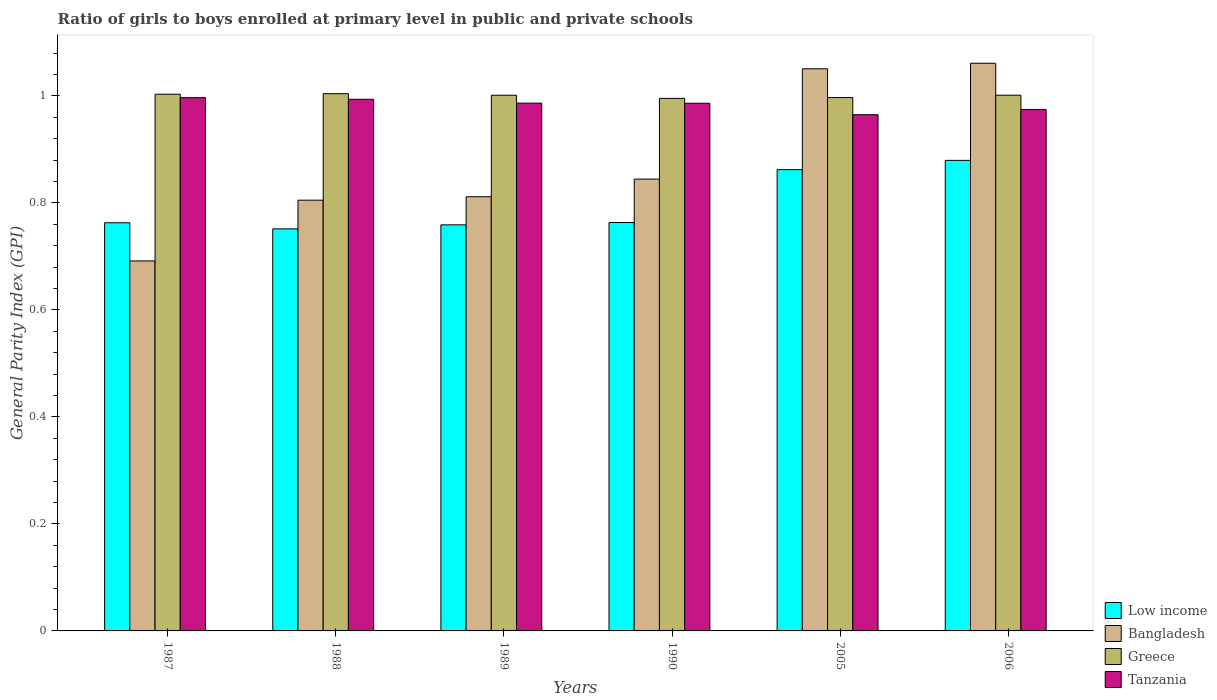How many different coloured bars are there?
Offer a terse response. 4. How many groups of bars are there?
Your answer should be very brief. 6. Are the number of bars per tick equal to the number of legend labels?
Ensure brevity in your answer.  Yes. How many bars are there on the 6th tick from the left?
Your answer should be very brief. 4. How many bars are there on the 2nd tick from the right?
Make the answer very short. 4. In how many cases, is the number of bars for a given year not equal to the number of legend labels?
Your answer should be compact. 0. What is the general parity index in Tanzania in 1988?
Your response must be concise. 0.99. Across all years, what is the maximum general parity index in Greece?
Give a very brief answer. 1. Across all years, what is the minimum general parity index in Greece?
Ensure brevity in your answer.  1. In which year was the general parity index in Bangladesh maximum?
Provide a short and direct response. 2006. What is the total general parity index in Bangladesh in the graph?
Offer a very short reply. 5.26. What is the difference between the general parity index in Tanzania in 1987 and that in 1990?
Make the answer very short. 0.01. What is the difference between the general parity index in Low income in 2005 and the general parity index in Bangladesh in 1989?
Make the answer very short. 0.05. What is the average general parity index in Low income per year?
Your response must be concise. 0.8. In the year 1987, what is the difference between the general parity index in Bangladesh and general parity index in Greece?
Your response must be concise. -0.31. In how many years, is the general parity index in Greece greater than 0.68?
Make the answer very short. 6. What is the ratio of the general parity index in Tanzania in 1987 to that in 2005?
Provide a short and direct response. 1.03. What is the difference between the highest and the second highest general parity index in Greece?
Your answer should be very brief. 0. What is the difference between the highest and the lowest general parity index in Low income?
Offer a terse response. 0.13. In how many years, is the general parity index in Greece greater than the average general parity index in Greece taken over all years?
Ensure brevity in your answer.  4. What does the 1st bar from the right in 1987 represents?
Provide a short and direct response. Tanzania. Is it the case that in every year, the sum of the general parity index in Bangladesh and general parity index in Low income is greater than the general parity index in Tanzania?
Offer a terse response. Yes. How many bars are there?
Provide a short and direct response. 24. Are all the bars in the graph horizontal?
Your answer should be very brief. No. Where does the legend appear in the graph?
Your response must be concise. Bottom right. What is the title of the graph?
Your answer should be compact. Ratio of girls to boys enrolled at primary level in public and private schools. What is the label or title of the X-axis?
Offer a very short reply. Years. What is the label or title of the Y-axis?
Your answer should be compact. General Parity Index (GPI). What is the General Parity Index (GPI) of Low income in 1987?
Give a very brief answer. 0.76. What is the General Parity Index (GPI) of Bangladesh in 1987?
Make the answer very short. 0.69. What is the General Parity Index (GPI) in Greece in 1987?
Ensure brevity in your answer.  1. What is the General Parity Index (GPI) in Tanzania in 1987?
Provide a short and direct response. 1. What is the General Parity Index (GPI) of Low income in 1988?
Offer a very short reply. 0.75. What is the General Parity Index (GPI) of Bangladesh in 1988?
Make the answer very short. 0.81. What is the General Parity Index (GPI) in Greece in 1988?
Give a very brief answer. 1. What is the General Parity Index (GPI) in Tanzania in 1988?
Your answer should be compact. 0.99. What is the General Parity Index (GPI) in Low income in 1989?
Keep it short and to the point. 0.76. What is the General Parity Index (GPI) of Bangladesh in 1989?
Give a very brief answer. 0.81. What is the General Parity Index (GPI) of Greece in 1989?
Provide a short and direct response. 1. What is the General Parity Index (GPI) of Tanzania in 1989?
Make the answer very short. 0.99. What is the General Parity Index (GPI) of Low income in 1990?
Ensure brevity in your answer.  0.76. What is the General Parity Index (GPI) in Bangladesh in 1990?
Offer a terse response. 0.84. What is the General Parity Index (GPI) in Greece in 1990?
Your response must be concise. 1. What is the General Parity Index (GPI) in Tanzania in 1990?
Keep it short and to the point. 0.99. What is the General Parity Index (GPI) of Low income in 2005?
Offer a terse response. 0.86. What is the General Parity Index (GPI) of Bangladesh in 2005?
Ensure brevity in your answer.  1.05. What is the General Parity Index (GPI) in Greece in 2005?
Offer a terse response. 1. What is the General Parity Index (GPI) of Tanzania in 2005?
Offer a very short reply. 0.96. What is the General Parity Index (GPI) in Low income in 2006?
Your response must be concise. 0.88. What is the General Parity Index (GPI) of Bangladesh in 2006?
Offer a very short reply. 1.06. What is the General Parity Index (GPI) of Greece in 2006?
Your response must be concise. 1. What is the General Parity Index (GPI) in Tanzania in 2006?
Give a very brief answer. 0.97. Across all years, what is the maximum General Parity Index (GPI) of Low income?
Offer a terse response. 0.88. Across all years, what is the maximum General Parity Index (GPI) in Bangladesh?
Your answer should be compact. 1.06. Across all years, what is the maximum General Parity Index (GPI) in Greece?
Offer a very short reply. 1. Across all years, what is the maximum General Parity Index (GPI) of Tanzania?
Make the answer very short. 1. Across all years, what is the minimum General Parity Index (GPI) in Low income?
Your answer should be very brief. 0.75. Across all years, what is the minimum General Parity Index (GPI) of Bangladesh?
Offer a very short reply. 0.69. Across all years, what is the minimum General Parity Index (GPI) of Greece?
Provide a short and direct response. 1. Across all years, what is the minimum General Parity Index (GPI) in Tanzania?
Your response must be concise. 0.96. What is the total General Parity Index (GPI) in Low income in the graph?
Keep it short and to the point. 4.78. What is the total General Parity Index (GPI) in Bangladesh in the graph?
Provide a short and direct response. 5.26. What is the total General Parity Index (GPI) in Greece in the graph?
Provide a short and direct response. 6. What is the total General Parity Index (GPI) in Tanzania in the graph?
Provide a short and direct response. 5.9. What is the difference between the General Parity Index (GPI) of Low income in 1987 and that in 1988?
Give a very brief answer. 0.01. What is the difference between the General Parity Index (GPI) in Bangladesh in 1987 and that in 1988?
Offer a very short reply. -0.11. What is the difference between the General Parity Index (GPI) of Greece in 1987 and that in 1988?
Your answer should be very brief. -0. What is the difference between the General Parity Index (GPI) of Tanzania in 1987 and that in 1988?
Offer a terse response. 0. What is the difference between the General Parity Index (GPI) in Low income in 1987 and that in 1989?
Your answer should be compact. 0. What is the difference between the General Parity Index (GPI) in Bangladesh in 1987 and that in 1989?
Offer a very short reply. -0.12. What is the difference between the General Parity Index (GPI) of Greece in 1987 and that in 1989?
Provide a short and direct response. 0. What is the difference between the General Parity Index (GPI) of Tanzania in 1987 and that in 1989?
Your response must be concise. 0.01. What is the difference between the General Parity Index (GPI) of Low income in 1987 and that in 1990?
Offer a very short reply. -0. What is the difference between the General Parity Index (GPI) in Bangladesh in 1987 and that in 1990?
Make the answer very short. -0.15. What is the difference between the General Parity Index (GPI) in Greece in 1987 and that in 1990?
Your response must be concise. 0.01. What is the difference between the General Parity Index (GPI) of Tanzania in 1987 and that in 1990?
Offer a very short reply. 0.01. What is the difference between the General Parity Index (GPI) in Low income in 1987 and that in 2005?
Give a very brief answer. -0.1. What is the difference between the General Parity Index (GPI) of Bangladesh in 1987 and that in 2005?
Make the answer very short. -0.36. What is the difference between the General Parity Index (GPI) in Greece in 1987 and that in 2005?
Provide a short and direct response. 0.01. What is the difference between the General Parity Index (GPI) in Tanzania in 1987 and that in 2005?
Provide a succinct answer. 0.03. What is the difference between the General Parity Index (GPI) of Low income in 1987 and that in 2006?
Provide a short and direct response. -0.12. What is the difference between the General Parity Index (GPI) in Bangladesh in 1987 and that in 2006?
Make the answer very short. -0.37. What is the difference between the General Parity Index (GPI) of Greece in 1987 and that in 2006?
Your answer should be very brief. 0. What is the difference between the General Parity Index (GPI) in Tanzania in 1987 and that in 2006?
Your response must be concise. 0.02. What is the difference between the General Parity Index (GPI) of Low income in 1988 and that in 1989?
Provide a short and direct response. -0.01. What is the difference between the General Parity Index (GPI) of Bangladesh in 1988 and that in 1989?
Provide a short and direct response. -0.01. What is the difference between the General Parity Index (GPI) of Greece in 1988 and that in 1989?
Provide a succinct answer. 0. What is the difference between the General Parity Index (GPI) in Tanzania in 1988 and that in 1989?
Offer a very short reply. 0.01. What is the difference between the General Parity Index (GPI) in Low income in 1988 and that in 1990?
Your answer should be very brief. -0.01. What is the difference between the General Parity Index (GPI) in Bangladesh in 1988 and that in 1990?
Your answer should be compact. -0.04. What is the difference between the General Parity Index (GPI) in Greece in 1988 and that in 1990?
Offer a very short reply. 0.01. What is the difference between the General Parity Index (GPI) of Tanzania in 1988 and that in 1990?
Your answer should be compact. 0.01. What is the difference between the General Parity Index (GPI) of Low income in 1988 and that in 2005?
Ensure brevity in your answer.  -0.11. What is the difference between the General Parity Index (GPI) in Bangladesh in 1988 and that in 2005?
Offer a very short reply. -0.25. What is the difference between the General Parity Index (GPI) in Greece in 1988 and that in 2005?
Keep it short and to the point. 0.01. What is the difference between the General Parity Index (GPI) in Tanzania in 1988 and that in 2005?
Keep it short and to the point. 0.03. What is the difference between the General Parity Index (GPI) of Low income in 1988 and that in 2006?
Provide a succinct answer. -0.13. What is the difference between the General Parity Index (GPI) of Bangladesh in 1988 and that in 2006?
Provide a succinct answer. -0.26. What is the difference between the General Parity Index (GPI) of Greece in 1988 and that in 2006?
Offer a very short reply. 0. What is the difference between the General Parity Index (GPI) of Tanzania in 1988 and that in 2006?
Make the answer very short. 0.02. What is the difference between the General Parity Index (GPI) of Low income in 1989 and that in 1990?
Provide a succinct answer. -0. What is the difference between the General Parity Index (GPI) in Bangladesh in 1989 and that in 1990?
Give a very brief answer. -0.03. What is the difference between the General Parity Index (GPI) in Greece in 1989 and that in 1990?
Offer a very short reply. 0.01. What is the difference between the General Parity Index (GPI) in Low income in 1989 and that in 2005?
Your answer should be compact. -0.1. What is the difference between the General Parity Index (GPI) in Bangladesh in 1989 and that in 2005?
Give a very brief answer. -0.24. What is the difference between the General Parity Index (GPI) of Greece in 1989 and that in 2005?
Your answer should be compact. 0. What is the difference between the General Parity Index (GPI) of Tanzania in 1989 and that in 2005?
Offer a terse response. 0.02. What is the difference between the General Parity Index (GPI) of Low income in 1989 and that in 2006?
Provide a short and direct response. -0.12. What is the difference between the General Parity Index (GPI) of Bangladesh in 1989 and that in 2006?
Offer a very short reply. -0.25. What is the difference between the General Parity Index (GPI) in Greece in 1989 and that in 2006?
Offer a very short reply. -0. What is the difference between the General Parity Index (GPI) in Tanzania in 1989 and that in 2006?
Keep it short and to the point. 0.01. What is the difference between the General Parity Index (GPI) in Low income in 1990 and that in 2005?
Your answer should be very brief. -0.1. What is the difference between the General Parity Index (GPI) in Bangladesh in 1990 and that in 2005?
Ensure brevity in your answer.  -0.21. What is the difference between the General Parity Index (GPI) of Greece in 1990 and that in 2005?
Keep it short and to the point. -0. What is the difference between the General Parity Index (GPI) in Tanzania in 1990 and that in 2005?
Offer a terse response. 0.02. What is the difference between the General Parity Index (GPI) of Low income in 1990 and that in 2006?
Offer a terse response. -0.12. What is the difference between the General Parity Index (GPI) in Bangladesh in 1990 and that in 2006?
Offer a terse response. -0.22. What is the difference between the General Parity Index (GPI) in Greece in 1990 and that in 2006?
Your answer should be compact. -0.01. What is the difference between the General Parity Index (GPI) in Tanzania in 1990 and that in 2006?
Make the answer very short. 0.01. What is the difference between the General Parity Index (GPI) of Low income in 2005 and that in 2006?
Keep it short and to the point. -0.02. What is the difference between the General Parity Index (GPI) of Bangladesh in 2005 and that in 2006?
Offer a terse response. -0.01. What is the difference between the General Parity Index (GPI) in Greece in 2005 and that in 2006?
Provide a short and direct response. -0. What is the difference between the General Parity Index (GPI) of Tanzania in 2005 and that in 2006?
Give a very brief answer. -0.01. What is the difference between the General Parity Index (GPI) of Low income in 1987 and the General Parity Index (GPI) of Bangladesh in 1988?
Offer a terse response. -0.04. What is the difference between the General Parity Index (GPI) in Low income in 1987 and the General Parity Index (GPI) in Greece in 1988?
Make the answer very short. -0.24. What is the difference between the General Parity Index (GPI) in Low income in 1987 and the General Parity Index (GPI) in Tanzania in 1988?
Provide a succinct answer. -0.23. What is the difference between the General Parity Index (GPI) in Bangladesh in 1987 and the General Parity Index (GPI) in Greece in 1988?
Offer a terse response. -0.31. What is the difference between the General Parity Index (GPI) in Bangladesh in 1987 and the General Parity Index (GPI) in Tanzania in 1988?
Provide a short and direct response. -0.3. What is the difference between the General Parity Index (GPI) of Greece in 1987 and the General Parity Index (GPI) of Tanzania in 1988?
Provide a short and direct response. 0.01. What is the difference between the General Parity Index (GPI) in Low income in 1987 and the General Parity Index (GPI) in Bangladesh in 1989?
Offer a very short reply. -0.05. What is the difference between the General Parity Index (GPI) of Low income in 1987 and the General Parity Index (GPI) of Greece in 1989?
Keep it short and to the point. -0.24. What is the difference between the General Parity Index (GPI) in Low income in 1987 and the General Parity Index (GPI) in Tanzania in 1989?
Make the answer very short. -0.22. What is the difference between the General Parity Index (GPI) of Bangladesh in 1987 and the General Parity Index (GPI) of Greece in 1989?
Offer a very short reply. -0.31. What is the difference between the General Parity Index (GPI) of Bangladesh in 1987 and the General Parity Index (GPI) of Tanzania in 1989?
Offer a very short reply. -0.29. What is the difference between the General Parity Index (GPI) of Greece in 1987 and the General Parity Index (GPI) of Tanzania in 1989?
Your answer should be very brief. 0.02. What is the difference between the General Parity Index (GPI) of Low income in 1987 and the General Parity Index (GPI) of Bangladesh in 1990?
Provide a succinct answer. -0.08. What is the difference between the General Parity Index (GPI) in Low income in 1987 and the General Parity Index (GPI) in Greece in 1990?
Provide a succinct answer. -0.23. What is the difference between the General Parity Index (GPI) in Low income in 1987 and the General Parity Index (GPI) in Tanzania in 1990?
Your response must be concise. -0.22. What is the difference between the General Parity Index (GPI) of Bangladesh in 1987 and the General Parity Index (GPI) of Greece in 1990?
Give a very brief answer. -0.3. What is the difference between the General Parity Index (GPI) in Bangladesh in 1987 and the General Parity Index (GPI) in Tanzania in 1990?
Make the answer very short. -0.29. What is the difference between the General Parity Index (GPI) of Greece in 1987 and the General Parity Index (GPI) of Tanzania in 1990?
Keep it short and to the point. 0.02. What is the difference between the General Parity Index (GPI) in Low income in 1987 and the General Parity Index (GPI) in Bangladesh in 2005?
Offer a very short reply. -0.29. What is the difference between the General Parity Index (GPI) of Low income in 1987 and the General Parity Index (GPI) of Greece in 2005?
Offer a terse response. -0.23. What is the difference between the General Parity Index (GPI) of Low income in 1987 and the General Parity Index (GPI) of Tanzania in 2005?
Your answer should be compact. -0.2. What is the difference between the General Parity Index (GPI) in Bangladesh in 1987 and the General Parity Index (GPI) in Greece in 2005?
Your answer should be compact. -0.31. What is the difference between the General Parity Index (GPI) of Bangladesh in 1987 and the General Parity Index (GPI) of Tanzania in 2005?
Your response must be concise. -0.27. What is the difference between the General Parity Index (GPI) of Greece in 1987 and the General Parity Index (GPI) of Tanzania in 2005?
Offer a terse response. 0.04. What is the difference between the General Parity Index (GPI) of Low income in 1987 and the General Parity Index (GPI) of Bangladesh in 2006?
Make the answer very short. -0.3. What is the difference between the General Parity Index (GPI) of Low income in 1987 and the General Parity Index (GPI) of Greece in 2006?
Ensure brevity in your answer.  -0.24. What is the difference between the General Parity Index (GPI) in Low income in 1987 and the General Parity Index (GPI) in Tanzania in 2006?
Your answer should be compact. -0.21. What is the difference between the General Parity Index (GPI) in Bangladesh in 1987 and the General Parity Index (GPI) in Greece in 2006?
Make the answer very short. -0.31. What is the difference between the General Parity Index (GPI) of Bangladesh in 1987 and the General Parity Index (GPI) of Tanzania in 2006?
Provide a succinct answer. -0.28. What is the difference between the General Parity Index (GPI) in Greece in 1987 and the General Parity Index (GPI) in Tanzania in 2006?
Your answer should be compact. 0.03. What is the difference between the General Parity Index (GPI) in Low income in 1988 and the General Parity Index (GPI) in Bangladesh in 1989?
Ensure brevity in your answer.  -0.06. What is the difference between the General Parity Index (GPI) in Low income in 1988 and the General Parity Index (GPI) in Greece in 1989?
Ensure brevity in your answer.  -0.25. What is the difference between the General Parity Index (GPI) of Low income in 1988 and the General Parity Index (GPI) of Tanzania in 1989?
Provide a short and direct response. -0.23. What is the difference between the General Parity Index (GPI) in Bangladesh in 1988 and the General Parity Index (GPI) in Greece in 1989?
Offer a very short reply. -0.2. What is the difference between the General Parity Index (GPI) of Bangladesh in 1988 and the General Parity Index (GPI) of Tanzania in 1989?
Make the answer very short. -0.18. What is the difference between the General Parity Index (GPI) in Greece in 1988 and the General Parity Index (GPI) in Tanzania in 1989?
Make the answer very short. 0.02. What is the difference between the General Parity Index (GPI) of Low income in 1988 and the General Parity Index (GPI) of Bangladesh in 1990?
Offer a terse response. -0.09. What is the difference between the General Parity Index (GPI) in Low income in 1988 and the General Parity Index (GPI) in Greece in 1990?
Offer a terse response. -0.24. What is the difference between the General Parity Index (GPI) in Low income in 1988 and the General Parity Index (GPI) in Tanzania in 1990?
Offer a terse response. -0.23. What is the difference between the General Parity Index (GPI) in Bangladesh in 1988 and the General Parity Index (GPI) in Greece in 1990?
Your answer should be very brief. -0.19. What is the difference between the General Parity Index (GPI) in Bangladesh in 1988 and the General Parity Index (GPI) in Tanzania in 1990?
Your response must be concise. -0.18. What is the difference between the General Parity Index (GPI) of Greece in 1988 and the General Parity Index (GPI) of Tanzania in 1990?
Offer a very short reply. 0.02. What is the difference between the General Parity Index (GPI) of Low income in 1988 and the General Parity Index (GPI) of Bangladesh in 2005?
Keep it short and to the point. -0.3. What is the difference between the General Parity Index (GPI) in Low income in 1988 and the General Parity Index (GPI) in Greece in 2005?
Keep it short and to the point. -0.25. What is the difference between the General Parity Index (GPI) of Low income in 1988 and the General Parity Index (GPI) of Tanzania in 2005?
Your answer should be compact. -0.21. What is the difference between the General Parity Index (GPI) of Bangladesh in 1988 and the General Parity Index (GPI) of Greece in 2005?
Your response must be concise. -0.19. What is the difference between the General Parity Index (GPI) in Bangladesh in 1988 and the General Parity Index (GPI) in Tanzania in 2005?
Your answer should be compact. -0.16. What is the difference between the General Parity Index (GPI) in Greece in 1988 and the General Parity Index (GPI) in Tanzania in 2005?
Offer a very short reply. 0.04. What is the difference between the General Parity Index (GPI) in Low income in 1988 and the General Parity Index (GPI) in Bangladesh in 2006?
Offer a very short reply. -0.31. What is the difference between the General Parity Index (GPI) in Low income in 1988 and the General Parity Index (GPI) in Greece in 2006?
Ensure brevity in your answer.  -0.25. What is the difference between the General Parity Index (GPI) in Low income in 1988 and the General Parity Index (GPI) in Tanzania in 2006?
Your response must be concise. -0.22. What is the difference between the General Parity Index (GPI) in Bangladesh in 1988 and the General Parity Index (GPI) in Greece in 2006?
Keep it short and to the point. -0.2. What is the difference between the General Parity Index (GPI) in Bangladesh in 1988 and the General Parity Index (GPI) in Tanzania in 2006?
Keep it short and to the point. -0.17. What is the difference between the General Parity Index (GPI) of Greece in 1988 and the General Parity Index (GPI) of Tanzania in 2006?
Provide a short and direct response. 0.03. What is the difference between the General Parity Index (GPI) in Low income in 1989 and the General Parity Index (GPI) in Bangladesh in 1990?
Your response must be concise. -0.09. What is the difference between the General Parity Index (GPI) of Low income in 1989 and the General Parity Index (GPI) of Greece in 1990?
Give a very brief answer. -0.24. What is the difference between the General Parity Index (GPI) of Low income in 1989 and the General Parity Index (GPI) of Tanzania in 1990?
Your answer should be compact. -0.23. What is the difference between the General Parity Index (GPI) in Bangladesh in 1989 and the General Parity Index (GPI) in Greece in 1990?
Your answer should be compact. -0.18. What is the difference between the General Parity Index (GPI) of Bangladesh in 1989 and the General Parity Index (GPI) of Tanzania in 1990?
Make the answer very short. -0.17. What is the difference between the General Parity Index (GPI) of Greece in 1989 and the General Parity Index (GPI) of Tanzania in 1990?
Your answer should be compact. 0.01. What is the difference between the General Parity Index (GPI) in Low income in 1989 and the General Parity Index (GPI) in Bangladesh in 2005?
Make the answer very short. -0.29. What is the difference between the General Parity Index (GPI) of Low income in 1989 and the General Parity Index (GPI) of Greece in 2005?
Provide a succinct answer. -0.24. What is the difference between the General Parity Index (GPI) in Low income in 1989 and the General Parity Index (GPI) in Tanzania in 2005?
Give a very brief answer. -0.21. What is the difference between the General Parity Index (GPI) in Bangladesh in 1989 and the General Parity Index (GPI) in Greece in 2005?
Make the answer very short. -0.19. What is the difference between the General Parity Index (GPI) of Bangladesh in 1989 and the General Parity Index (GPI) of Tanzania in 2005?
Offer a terse response. -0.15. What is the difference between the General Parity Index (GPI) of Greece in 1989 and the General Parity Index (GPI) of Tanzania in 2005?
Provide a short and direct response. 0.04. What is the difference between the General Parity Index (GPI) in Low income in 1989 and the General Parity Index (GPI) in Bangladesh in 2006?
Your answer should be compact. -0.3. What is the difference between the General Parity Index (GPI) in Low income in 1989 and the General Parity Index (GPI) in Greece in 2006?
Give a very brief answer. -0.24. What is the difference between the General Parity Index (GPI) in Low income in 1989 and the General Parity Index (GPI) in Tanzania in 2006?
Make the answer very short. -0.22. What is the difference between the General Parity Index (GPI) in Bangladesh in 1989 and the General Parity Index (GPI) in Greece in 2006?
Offer a terse response. -0.19. What is the difference between the General Parity Index (GPI) of Bangladesh in 1989 and the General Parity Index (GPI) of Tanzania in 2006?
Provide a succinct answer. -0.16. What is the difference between the General Parity Index (GPI) of Greece in 1989 and the General Parity Index (GPI) of Tanzania in 2006?
Your response must be concise. 0.03. What is the difference between the General Parity Index (GPI) in Low income in 1990 and the General Parity Index (GPI) in Bangladesh in 2005?
Offer a terse response. -0.29. What is the difference between the General Parity Index (GPI) in Low income in 1990 and the General Parity Index (GPI) in Greece in 2005?
Make the answer very short. -0.23. What is the difference between the General Parity Index (GPI) of Low income in 1990 and the General Parity Index (GPI) of Tanzania in 2005?
Make the answer very short. -0.2. What is the difference between the General Parity Index (GPI) of Bangladesh in 1990 and the General Parity Index (GPI) of Greece in 2005?
Your response must be concise. -0.15. What is the difference between the General Parity Index (GPI) in Bangladesh in 1990 and the General Parity Index (GPI) in Tanzania in 2005?
Offer a very short reply. -0.12. What is the difference between the General Parity Index (GPI) in Greece in 1990 and the General Parity Index (GPI) in Tanzania in 2005?
Offer a very short reply. 0.03. What is the difference between the General Parity Index (GPI) in Low income in 1990 and the General Parity Index (GPI) in Bangladesh in 2006?
Your answer should be compact. -0.3. What is the difference between the General Parity Index (GPI) in Low income in 1990 and the General Parity Index (GPI) in Greece in 2006?
Provide a succinct answer. -0.24. What is the difference between the General Parity Index (GPI) of Low income in 1990 and the General Parity Index (GPI) of Tanzania in 2006?
Give a very brief answer. -0.21. What is the difference between the General Parity Index (GPI) of Bangladesh in 1990 and the General Parity Index (GPI) of Greece in 2006?
Keep it short and to the point. -0.16. What is the difference between the General Parity Index (GPI) of Bangladesh in 1990 and the General Parity Index (GPI) of Tanzania in 2006?
Give a very brief answer. -0.13. What is the difference between the General Parity Index (GPI) of Greece in 1990 and the General Parity Index (GPI) of Tanzania in 2006?
Ensure brevity in your answer.  0.02. What is the difference between the General Parity Index (GPI) of Low income in 2005 and the General Parity Index (GPI) of Bangladesh in 2006?
Keep it short and to the point. -0.2. What is the difference between the General Parity Index (GPI) in Low income in 2005 and the General Parity Index (GPI) in Greece in 2006?
Offer a very short reply. -0.14. What is the difference between the General Parity Index (GPI) of Low income in 2005 and the General Parity Index (GPI) of Tanzania in 2006?
Provide a short and direct response. -0.11. What is the difference between the General Parity Index (GPI) of Bangladesh in 2005 and the General Parity Index (GPI) of Greece in 2006?
Provide a succinct answer. 0.05. What is the difference between the General Parity Index (GPI) of Bangladesh in 2005 and the General Parity Index (GPI) of Tanzania in 2006?
Offer a very short reply. 0.08. What is the difference between the General Parity Index (GPI) in Greece in 2005 and the General Parity Index (GPI) in Tanzania in 2006?
Ensure brevity in your answer.  0.02. What is the average General Parity Index (GPI) in Low income per year?
Offer a terse response. 0.8. What is the average General Parity Index (GPI) in Bangladesh per year?
Ensure brevity in your answer.  0.88. What is the average General Parity Index (GPI) of Greece per year?
Give a very brief answer. 1. What is the average General Parity Index (GPI) in Tanzania per year?
Your response must be concise. 0.98. In the year 1987, what is the difference between the General Parity Index (GPI) of Low income and General Parity Index (GPI) of Bangladesh?
Provide a short and direct response. 0.07. In the year 1987, what is the difference between the General Parity Index (GPI) in Low income and General Parity Index (GPI) in Greece?
Provide a short and direct response. -0.24. In the year 1987, what is the difference between the General Parity Index (GPI) of Low income and General Parity Index (GPI) of Tanzania?
Provide a succinct answer. -0.23. In the year 1987, what is the difference between the General Parity Index (GPI) of Bangladesh and General Parity Index (GPI) of Greece?
Your answer should be compact. -0.31. In the year 1987, what is the difference between the General Parity Index (GPI) in Bangladesh and General Parity Index (GPI) in Tanzania?
Offer a very short reply. -0.31. In the year 1987, what is the difference between the General Parity Index (GPI) of Greece and General Parity Index (GPI) of Tanzania?
Your answer should be compact. 0.01. In the year 1988, what is the difference between the General Parity Index (GPI) in Low income and General Parity Index (GPI) in Bangladesh?
Provide a short and direct response. -0.05. In the year 1988, what is the difference between the General Parity Index (GPI) of Low income and General Parity Index (GPI) of Greece?
Keep it short and to the point. -0.25. In the year 1988, what is the difference between the General Parity Index (GPI) of Low income and General Parity Index (GPI) of Tanzania?
Offer a very short reply. -0.24. In the year 1988, what is the difference between the General Parity Index (GPI) in Bangladesh and General Parity Index (GPI) in Greece?
Your answer should be compact. -0.2. In the year 1988, what is the difference between the General Parity Index (GPI) in Bangladesh and General Parity Index (GPI) in Tanzania?
Provide a succinct answer. -0.19. In the year 1988, what is the difference between the General Parity Index (GPI) of Greece and General Parity Index (GPI) of Tanzania?
Offer a terse response. 0.01. In the year 1989, what is the difference between the General Parity Index (GPI) in Low income and General Parity Index (GPI) in Bangladesh?
Your answer should be very brief. -0.05. In the year 1989, what is the difference between the General Parity Index (GPI) in Low income and General Parity Index (GPI) in Greece?
Your answer should be very brief. -0.24. In the year 1989, what is the difference between the General Parity Index (GPI) in Low income and General Parity Index (GPI) in Tanzania?
Offer a very short reply. -0.23. In the year 1989, what is the difference between the General Parity Index (GPI) in Bangladesh and General Parity Index (GPI) in Greece?
Provide a short and direct response. -0.19. In the year 1989, what is the difference between the General Parity Index (GPI) of Bangladesh and General Parity Index (GPI) of Tanzania?
Keep it short and to the point. -0.17. In the year 1989, what is the difference between the General Parity Index (GPI) of Greece and General Parity Index (GPI) of Tanzania?
Your response must be concise. 0.01. In the year 1990, what is the difference between the General Parity Index (GPI) of Low income and General Parity Index (GPI) of Bangladesh?
Offer a very short reply. -0.08. In the year 1990, what is the difference between the General Parity Index (GPI) of Low income and General Parity Index (GPI) of Greece?
Give a very brief answer. -0.23. In the year 1990, what is the difference between the General Parity Index (GPI) in Low income and General Parity Index (GPI) in Tanzania?
Offer a terse response. -0.22. In the year 1990, what is the difference between the General Parity Index (GPI) of Bangladesh and General Parity Index (GPI) of Greece?
Your answer should be compact. -0.15. In the year 1990, what is the difference between the General Parity Index (GPI) in Bangladesh and General Parity Index (GPI) in Tanzania?
Your response must be concise. -0.14. In the year 1990, what is the difference between the General Parity Index (GPI) of Greece and General Parity Index (GPI) of Tanzania?
Ensure brevity in your answer.  0.01. In the year 2005, what is the difference between the General Parity Index (GPI) of Low income and General Parity Index (GPI) of Bangladesh?
Provide a succinct answer. -0.19. In the year 2005, what is the difference between the General Parity Index (GPI) in Low income and General Parity Index (GPI) in Greece?
Your response must be concise. -0.13. In the year 2005, what is the difference between the General Parity Index (GPI) of Low income and General Parity Index (GPI) of Tanzania?
Ensure brevity in your answer.  -0.1. In the year 2005, what is the difference between the General Parity Index (GPI) of Bangladesh and General Parity Index (GPI) of Greece?
Offer a very short reply. 0.05. In the year 2005, what is the difference between the General Parity Index (GPI) in Bangladesh and General Parity Index (GPI) in Tanzania?
Your answer should be compact. 0.09. In the year 2005, what is the difference between the General Parity Index (GPI) in Greece and General Parity Index (GPI) in Tanzania?
Your response must be concise. 0.03. In the year 2006, what is the difference between the General Parity Index (GPI) in Low income and General Parity Index (GPI) in Bangladesh?
Offer a terse response. -0.18. In the year 2006, what is the difference between the General Parity Index (GPI) in Low income and General Parity Index (GPI) in Greece?
Give a very brief answer. -0.12. In the year 2006, what is the difference between the General Parity Index (GPI) of Low income and General Parity Index (GPI) of Tanzania?
Keep it short and to the point. -0.1. In the year 2006, what is the difference between the General Parity Index (GPI) of Bangladesh and General Parity Index (GPI) of Greece?
Offer a very short reply. 0.06. In the year 2006, what is the difference between the General Parity Index (GPI) in Bangladesh and General Parity Index (GPI) in Tanzania?
Make the answer very short. 0.09. In the year 2006, what is the difference between the General Parity Index (GPI) in Greece and General Parity Index (GPI) in Tanzania?
Provide a succinct answer. 0.03. What is the ratio of the General Parity Index (GPI) of Low income in 1987 to that in 1988?
Keep it short and to the point. 1.02. What is the ratio of the General Parity Index (GPI) of Bangladesh in 1987 to that in 1988?
Make the answer very short. 0.86. What is the ratio of the General Parity Index (GPI) in Tanzania in 1987 to that in 1988?
Offer a terse response. 1. What is the ratio of the General Parity Index (GPI) of Low income in 1987 to that in 1989?
Offer a very short reply. 1.01. What is the ratio of the General Parity Index (GPI) of Bangladesh in 1987 to that in 1989?
Ensure brevity in your answer.  0.85. What is the ratio of the General Parity Index (GPI) of Tanzania in 1987 to that in 1989?
Offer a very short reply. 1.01. What is the ratio of the General Parity Index (GPI) in Bangladesh in 1987 to that in 1990?
Your response must be concise. 0.82. What is the ratio of the General Parity Index (GPI) in Tanzania in 1987 to that in 1990?
Your response must be concise. 1.01. What is the ratio of the General Parity Index (GPI) of Low income in 1987 to that in 2005?
Your response must be concise. 0.88. What is the ratio of the General Parity Index (GPI) of Bangladesh in 1987 to that in 2005?
Keep it short and to the point. 0.66. What is the ratio of the General Parity Index (GPI) in Tanzania in 1987 to that in 2005?
Keep it short and to the point. 1.03. What is the ratio of the General Parity Index (GPI) in Low income in 1987 to that in 2006?
Offer a terse response. 0.87. What is the ratio of the General Parity Index (GPI) of Bangladesh in 1987 to that in 2006?
Give a very brief answer. 0.65. What is the ratio of the General Parity Index (GPI) in Greece in 1987 to that in 2006?
Offer a very short reply. 1. What is the ratio of the General Parity Index (GPI) of Tanzania in 1987 to that in 2006?
Provide a short and direct response. 1.02. What is the ratio of the General Parity Index (GPI) of Bangladesh in 1988 to that in 1989?
Provide a short and direct response. 0.99. What is the ratio of the General Parity Index (GPI) of Tanzania in 1988 to that in 1989?
Your answer should be compact. 1.01. What is the ratio of the General Parity Index (GPI) in Low income in 1988 to that in 1990?
Offer a very short reply. 0.98. What is the ratio of the General Parity Index (GPI) in Bangladesh in 1988 to that in 1990?
Provide a short and direct response. 0.95. What is the ratio of the General Parity Index (GPI) in Greece in 1988 to that in 1990?
Ensure brevity in your answer.  1.01. What is the ratio of the General Parity Index (GPI) in Tanzania in 1988 to that in 1990?
Your response must be concise. 1.01. What is the ratio of the General Parity Index (GPI) of Low income in 1988 to that in 2005?
Provide a short and direct response. 0.87. What is the ratio of the General Parity Index (GPI) of Bangladesh in 1988 to that in 2005?
Your answer should be very brief. 0.77. What is the ratio of the General Parity Index (GPI) of Greece in 1988 to that in 2005?
Offer a very short reply. 1.01. What is the ratio of the General Parity Index (GPI) in Tanzania in 1988 to that in 2005?
Your response must be concise. 1.03. What is the ratio of the General Parity Index (GPI) of Low income in 1988 to that in 2006?
Ensure brevity in your answer.  0.85. What is the ratio of the General Parity Index (GPI) in Bangladesh in 1988 to that in 2006?
Keep it short and to the point. 0.76. What is the ratio of the General Parity Index (GPI) in Greece in 1988 to that in 2006?
Keep it short and to the point. 1. What is the ratio of the General Parity Index (GPI) of Tanzania in 1988 to that in 2006?
Your answer should be very brief. 1.02. What is the ratio of the General Parity Index (GPI) in Low income in 1989 to that in 1990?
Provide a short and direct response. 0.99. What is the ratio of the General Parity Index (GPI) in Bangladesh in 1989 to that in 1990?
Keep it short and to the point. 0.96. What is the ratio of the General Parity Index (GPI) of Greece in 1989 to that in 1990?
Give a very brief answer. 1.01. What is the ratio of the General Parity Index (GPI) of Tanzania in 1989 to that in 1990?
Offer a very short reply. 1. What is the ratio of the General Parity Index (GPI) of Low income in 1989 to that in 2005?
Provide a succinct answer. 0.88. What is the ratio of the General Parity Index (GPI) of Bangladesh in 1989 to that in 2005?
Give a very brief answer. 0.77. What is the ratio of the General Parity Index (GPI) of Tanzania in 1989 to that in 2005?
Offer a terse response. 1.02. What is the ratio of the General Parity Index (GPI) of Low income in 1989 to that in 2006?
Offer a very short reply. 0.86. What is the ratio of the General Parity Index (GPI) of Bangladesh in 1989 to that in 2006?
Provide a short and direct response. 0.76. What is the ratio of the General Parity Index (GPI) in Greece in 1989 to that in 2006?
Provide a short and direct response. 1. What is the ratio of the General Parity Index (GPI) in Tanzania in 1989 to that in 2006?
Offer a very short reply. 1.01. What is the ratio of the General Parity Index (GPI) in Low income in 1990 to that in 2005?
Your answer should be compact. 0.89. What is the ratio of the General Parity Index (GPI) of Bangladesh in 1990 to that in 2005?
Offer a very short reply. 0.8. What is the ratio of the General Parity Index (GPI) in Greece in 1990 to that in 2005?
Your answer should be compact. 1. What is the ratio of the General Parity Index (GPI) of Tanzania in 1990 to that in 2005?
Provide a short and direct response. 1.02. What is the ratio of the General Parity Index (GPI) in Low income in 1990 to that in 2006?
Your answer should be compact. 0.87. What is the ratio of the General Parity Index (GPI) of Bangladesh in 1990 to that in 2006?
Your answer should be compact. 0.8. What is the ratio of the General Parity Index (GPI) of Tanzania in 1990 to that in 2006?
Provide a succinct answer. 1.01. What is the ratio of the General Parity Index (GPI) in Low income in 2005 to that in 2006?
Give a very brief answer. 0.98. What is the ratio of the General Parity Index (GPI) of Bangladesh in 2005 to that in 2006?
Keep it short and to the point. 0.99. What is the ratio of the General Parity Index (GPI) in Tanzania in 2005 to that in 2006?
Provide a succinct answer. 0.99. What is the difference between the highest and the second highest General Parity Index (GPI) in Low income?
Make the answer very short. 0.02. What is the difference between the highest and the second highest General Parity Index (GPI) in Bangladesh?
Provide a short and direct response. 0.01. What is the difference between the highest and the second highest General Parity Index (GPI) of Greece?
Your answer should be compact. 0. What is the difference between the highest and the second highest General Parity Index (GPI) of Tanzania?
Your answer should be very brief. 0. What is the difference between the highest and the lowest General Parity Index (GPI) in Low income?
Offer a very short reply. 0.13. What is the difference between the highest and the lowest General Parity Index (GPI) of Bangladesh?
Provide a succinct answer. 0.37. What is the difference between the highest and the lowest General Parity Index (GPI) in Greece?
Make the answer very short. 0.01. What is the difference between the highest and the lowest General Parity Index (GPI) of Tanzania?
Provide a short and direct response. 0.03. 